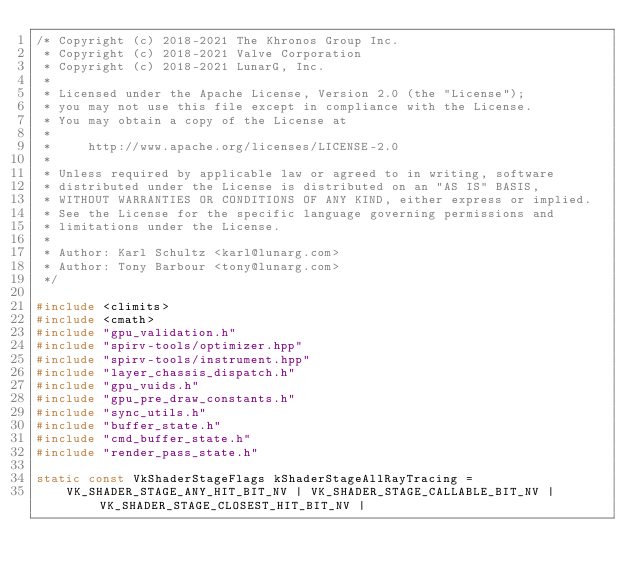<code> <loc_0><loc_0><loc_500><loc_500><_C++_>/* Copyright (c) 2018-2021 The Khronos Group Inc.
 * Copyright (c) 2018-2021 Valve Corporation
 * Copyright (c) 2018-2021 LunarG, Inc.
 *
 * Licensed under the Apache License, Version 2.0 (the "License");
 * you may not use this file except in compliance with the License.
 * You may obtain a copy of the License at
 *
 *     http://www.apache.org/licenses/LICENSE-2.0
 *
 * Unless required by applicable law or agreed to in writing, software
 * distributed under the License is distributed on an "AS IS" BASIS,
 * WITHOUT WARRANTIES OR CONDITIONS OF ANY KIND, either express or implied.
 * See the License for the specific language governing permissions and
 * limitations under the License.
 *
 * Author: Karl Schultz <karl@lunarg.com>
 * Author: Tony Barbour <tony@lunarg.com>
 */

#include <climits>
#include <cmath>
#include "gpu_validation.h"
#include "spirv-tools/optimizer.hpp"
#include "spirv-tools/instrument.hpp"
#include "layer_chassis_dispatch.h"
#include "gpu_vuids.h"
#include "gpu_pre_draw_constants.h"
#include "sync_utils.h"
#include "buffer_state.h"
#include "cmd_buffer_state.h"
#include "render_pass_state.h"

static const VkShaderStageFlags kShaderStageAllRayTracing =
    VK_SHADER_STAGE_ANY_HIT_BIT_NV | VK_SHADER_STAGE_CALLABLE_BIT_NV | VK_SHADER_STAGE_CLOSEST_HIT_BIT_NV |</code> 